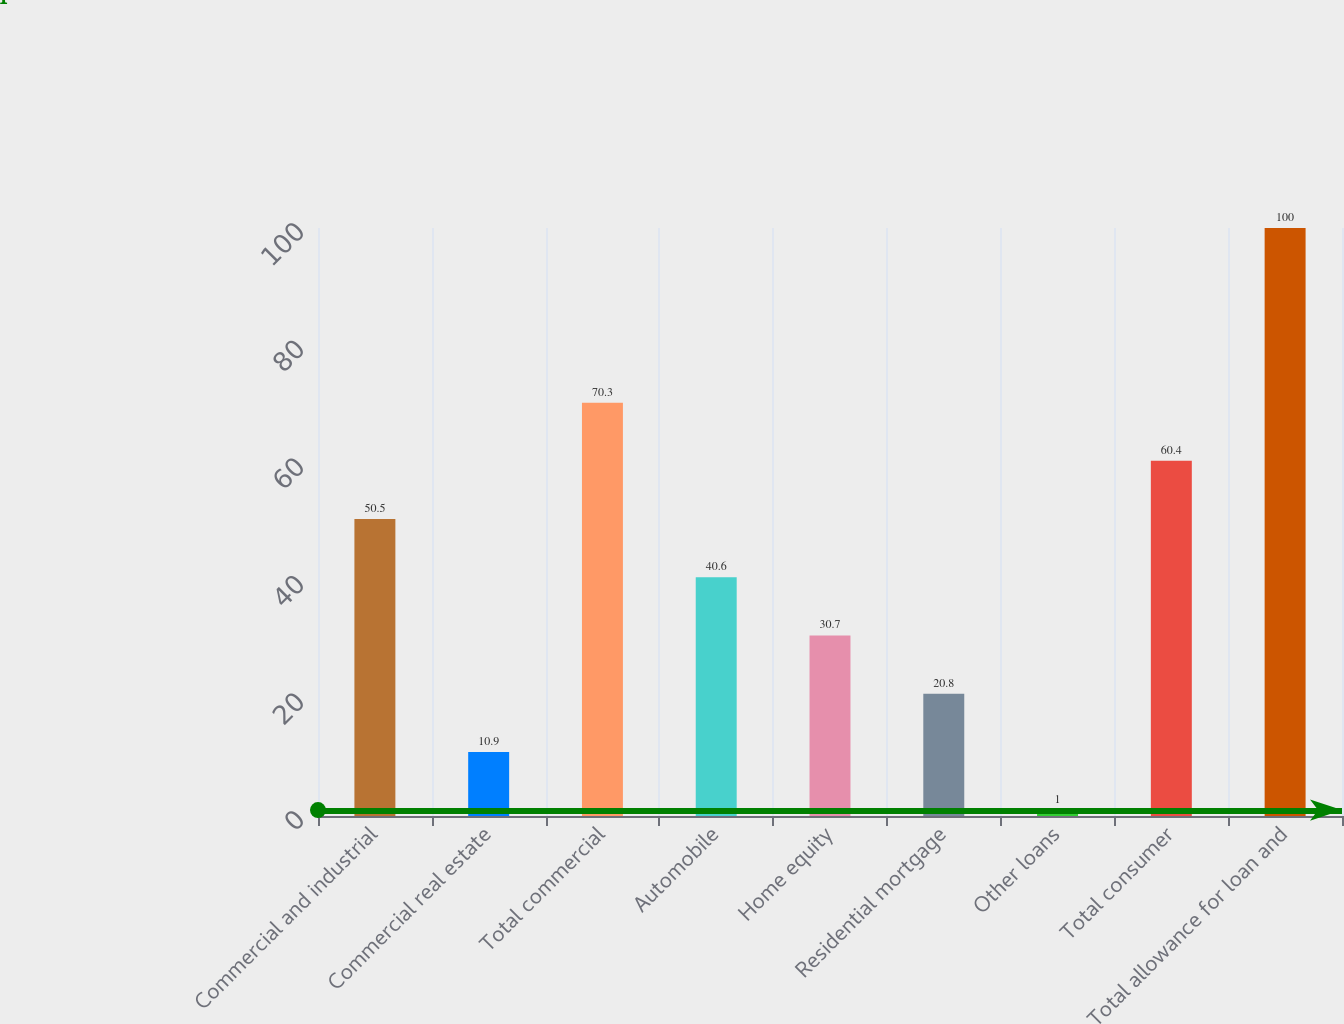Convert chart to OTSL. <chart><loc_0><loc_0><loc_500><loc_500><bar_chart><fcel>Commercial and industrial<fcel>Commercial real estate<fcel>Total commercial<fcel>Automobile<fcel>Home equity<fcel>Residential mortgage<fcel>Other loans<fcel>Total consumer<fcel>Total allowance for loan and<nl><fcel>50.5<fcel>10.9<fcel>70.3<fcel>40.6<fcel>30.7<fcel>20.8<fcel>1<fcel>60.4<fcel>100<nl></chart> 